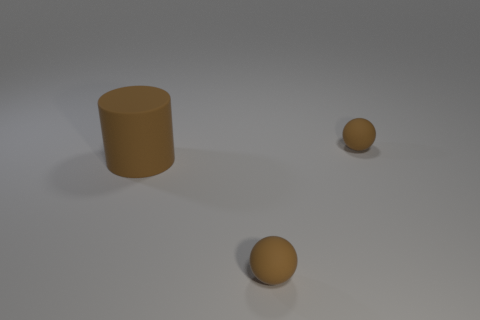Add 2 large brown cubes. How many objects exist? 5 Subtract all cylinders. How many objects are left? 2 Add 1 tiny things. How many tiny things exist? 3 Subtract 0 purple cubes. How many objects are left? 3 Subtract all large brown rubber cylinders. Subtract all big purple things. How many objects are left? 2 Add 2 brown rubber things. How many brown rubber things are left? 5 